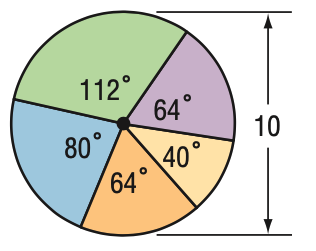Question: Find the area of the blue region.
Choices:
A. 8.7
B. 14.0
C. 17.5
D. 24.4
Answer with the letter. Answer: C 